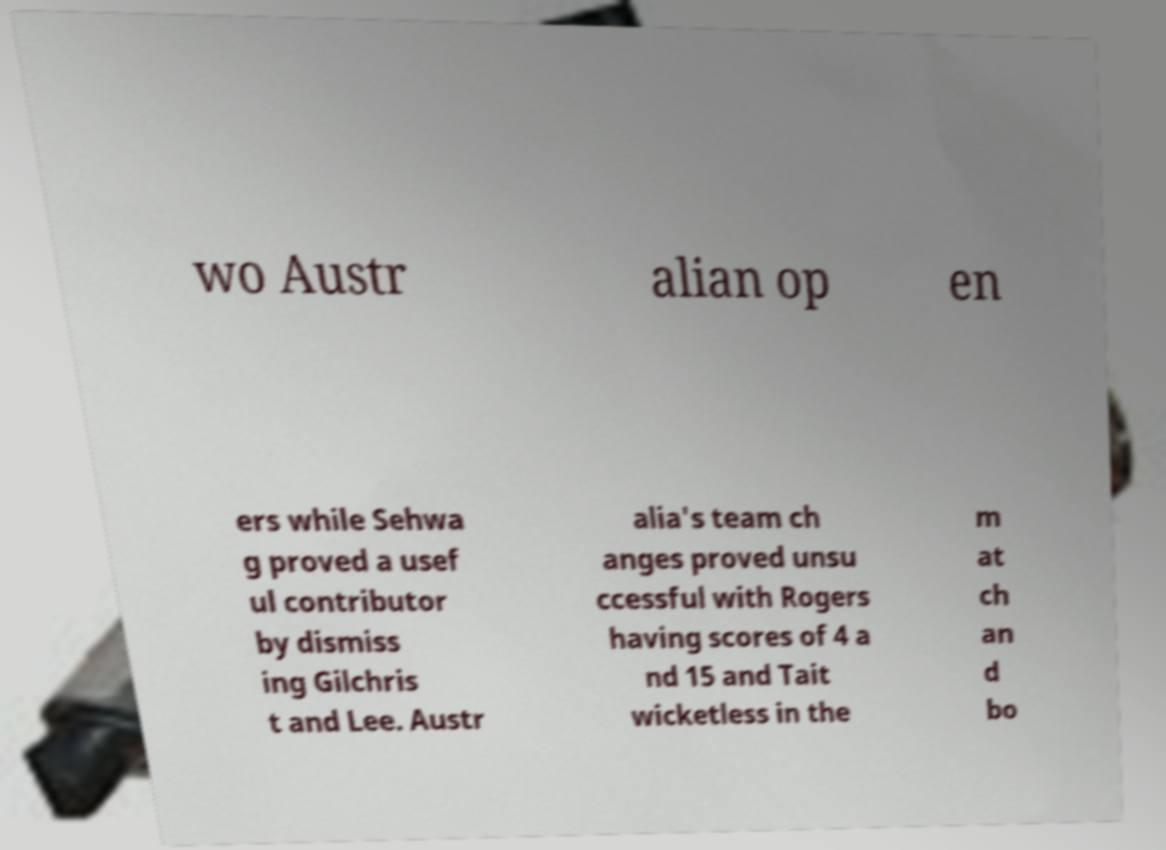What messages or text are displayed in this image? I need them in a readable, typed format. wo Austr alian op en ers while Sehwa g proved a usef ul contributor by dismiss ing Gilchris t and Lee. Austr alia's team ch anges proved unsu ccessful with Rogers having scores of 4 a nd 15 and Tait wicketless in the m at ch an d bo 